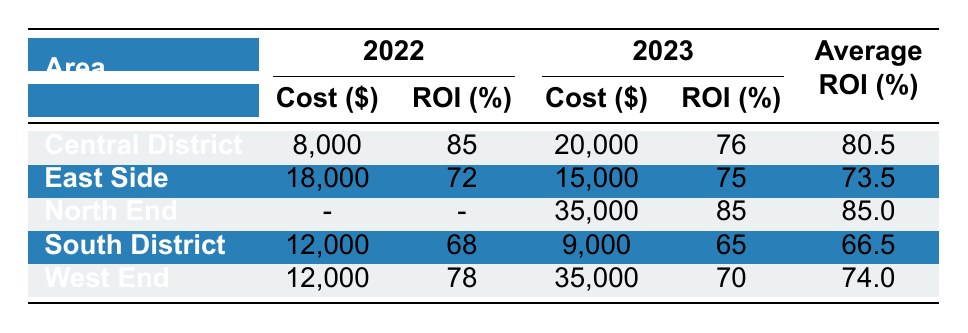What is the highest return on investment percentage among the renovations in the table? Looking at the ROI percentages listed for the renovations, we find the highest is 90% for landscaping in North End.
Answer: 90% Which area had the lowest average ROI percentage? To find the area with the lowest average ROI, we first look at the average ROI values: Central District (80.5%), East Side (73.5%), North End (85%), South District (66.5%), and West End (74%). The lowest average ROI is for the South District at 66.5%.
Answer: South District How much did the kitchen remodel cost compared to the average renovation cost in 2023? The kitchen remodel cost is $25,000. To find the average for 2023, we look at the costs for North End ($35,000), West End ($35,000), East Side ($15,000), and Central District ($20,000), which gives us an average = (35,000 + 15,000 + 35,000 + 20,000) / 4 = $26,250. Since $25,000 is less than $26,250, the kitchen remodel cost is lower than the average.
Answer: Lower Is there any renovation type that shows an ROI of over 85%? The ROI percentages for different renovation types are as follows: Kitchen Remodel (80%), Bathroom Upgrade (75%), and Landscaping (90%). Since landscaping has an ROI of 90%, there indeed is a renovation type with an ROI over 85%.
Answer: Yes How do the renovation costs for the West End in 2023 compare to 2022? The renovation cost for the West End in 2022 is $12,000, while in 2023 it is $35,000. To compare, $35,000 is significantly higher than $12,000, indicating an increase in renovation costs.
Answer: Increased Which area had the best ROI in 2022 and what was the renovation type? In 2022, the Central District had the highest ROI with 85% for the renovation type of exterior painting.
Answer: Central District, Exterior Painting What is the total cost of renovations in the South District across both years? The costs in the South District include $12,000 in 2022 and $9,000 in 2023. Adding these gives us $12,000 + $9,000 = $21,000 total cost for renovations in the South District.
Answer: $21,000 Based on the table, does the East Side consistently show a higher ROI in 2023 compared to 2022? In 2022, the East Side had an ROI of 72% and in 2023, the ROI increased to 75%. Thus, the East Side does show a consistent improvement in ROI between the two years.
Answer: Yes 